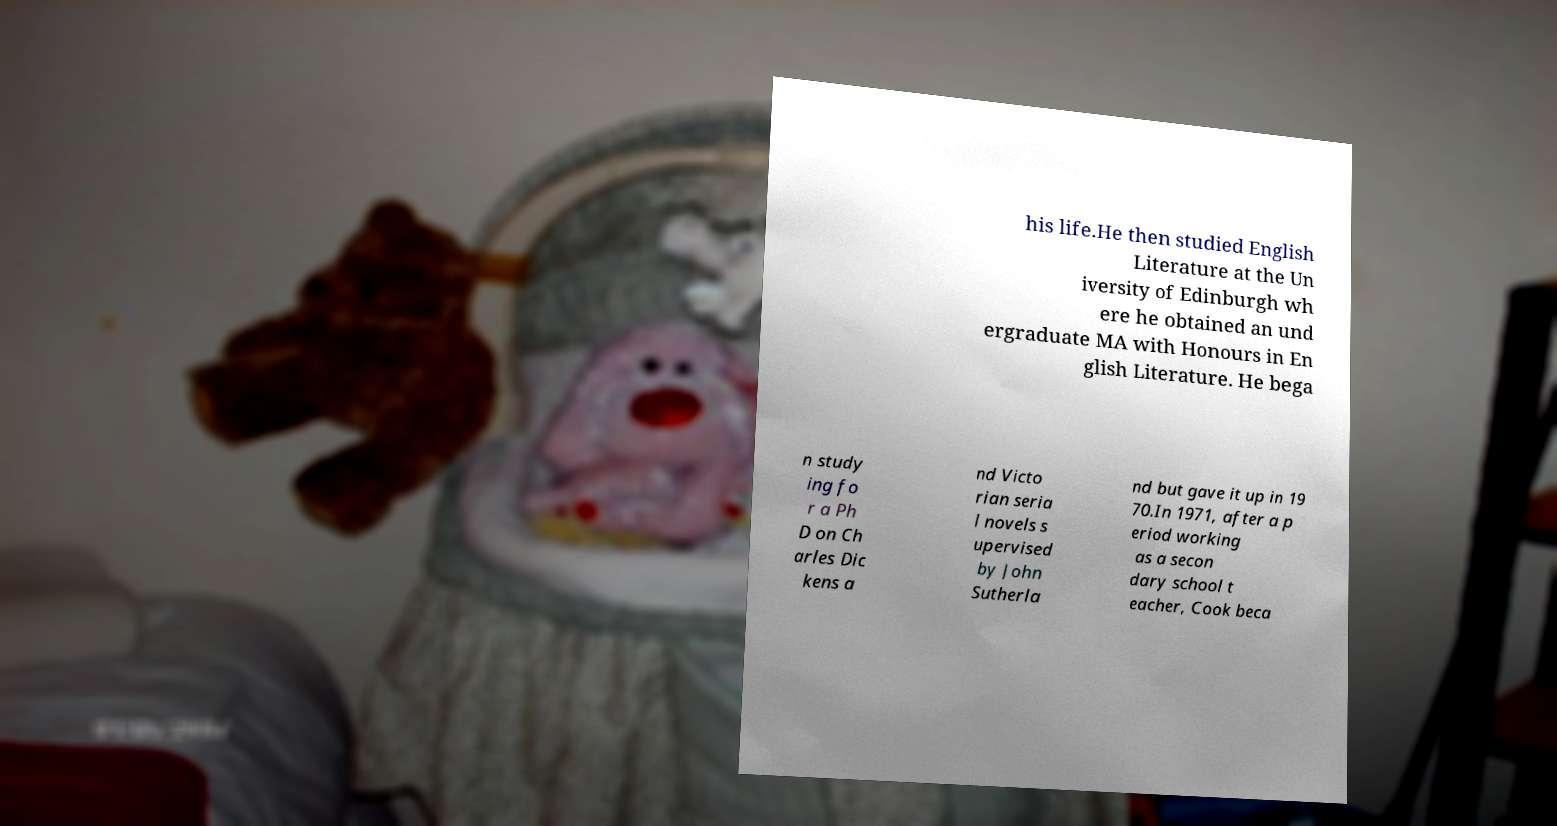Can you read and provide the text displayed in the image?This photo seems to have some interesting text. Can you extract and type it out for me? his life.He then studied English Literature at the Un iversity of Edinburgh wh ere he obtained an und ergraduate MA with Honours in En glish Literature. He bega n study ing fo r a Ph D on Ch arles Dic kens a nd Victo rian seria l novels s upervised by John Sutherla nd but gave it up in 19 70.In 1971, after a p eriod working as a secon dary school t eacher, Cook beca 